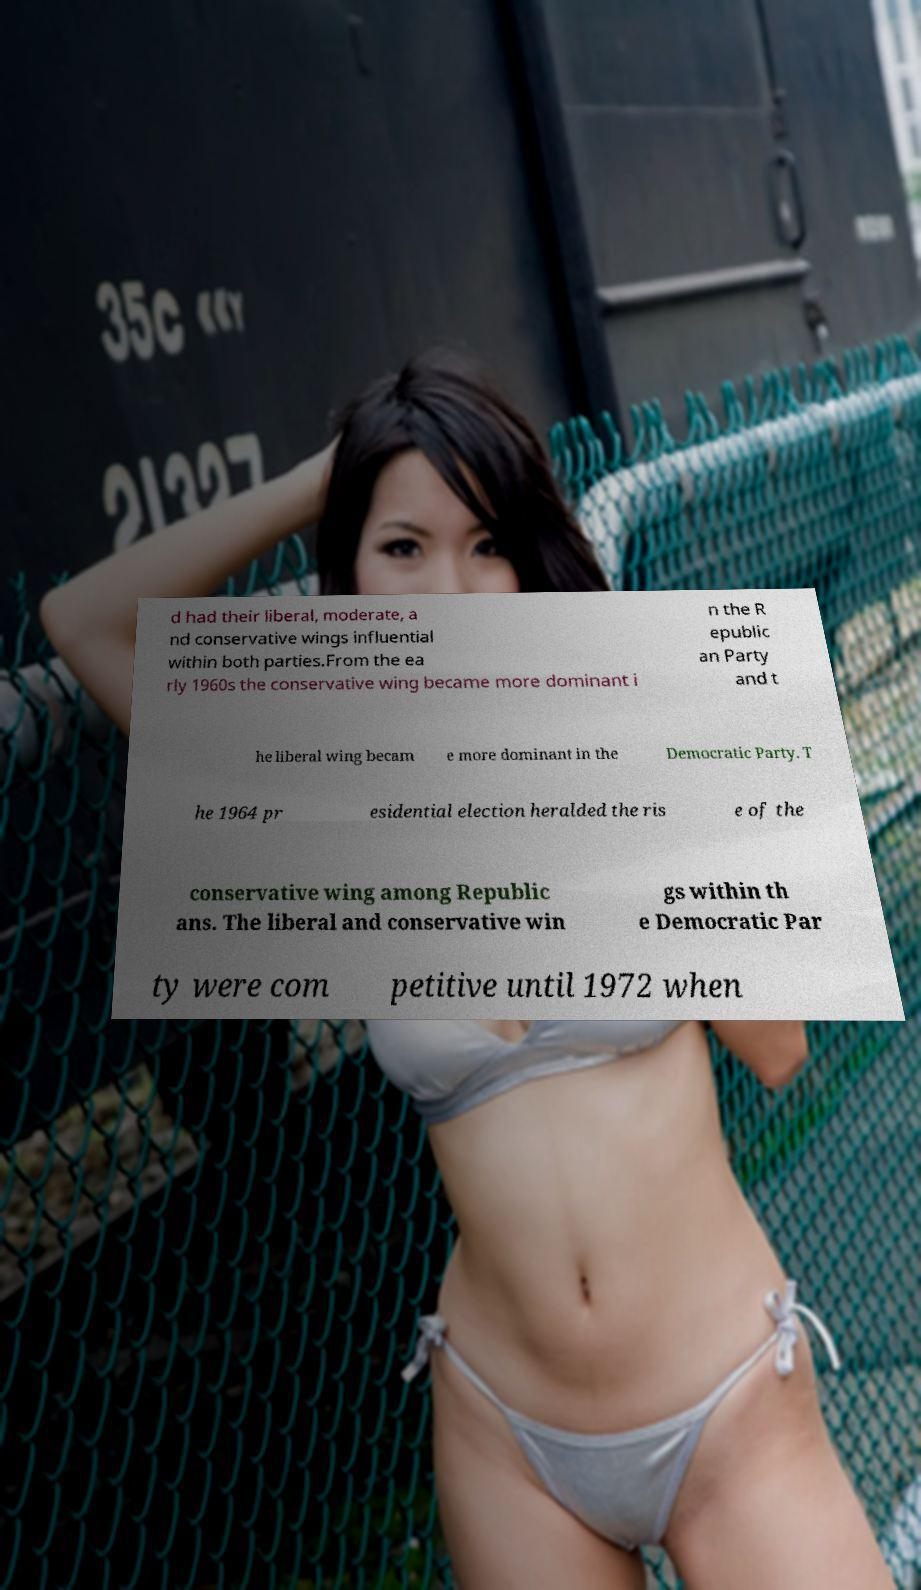Can you accurately transcribe the text from the provided image for me? d had their liberal, moderate, a nd conservative wings influential within both parties.From the ea rly 1960s the conservative wing became more dominant i n the R epublic an Party and t he liberal wing becam e more dominant in the Democratic Party. T he 1964 pr esidential election heralded the ris e of the conservative wing among Republic ans. The liberal and conservative win gs within th e Democratic Par ty were com petitive until 1972 when 